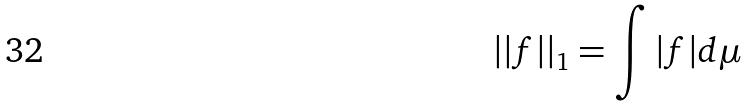Convert formula to latex. <formula><loc_0><loc_0><loc_500><loc_500>| | f | | _ { 1 } = \int | f | d \mu</formula> 